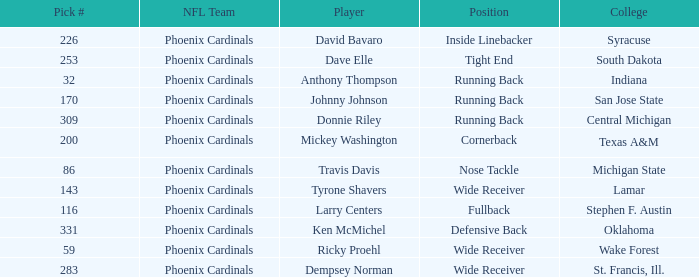Which player was a running back from San Jose State? Johnny Johnson. 